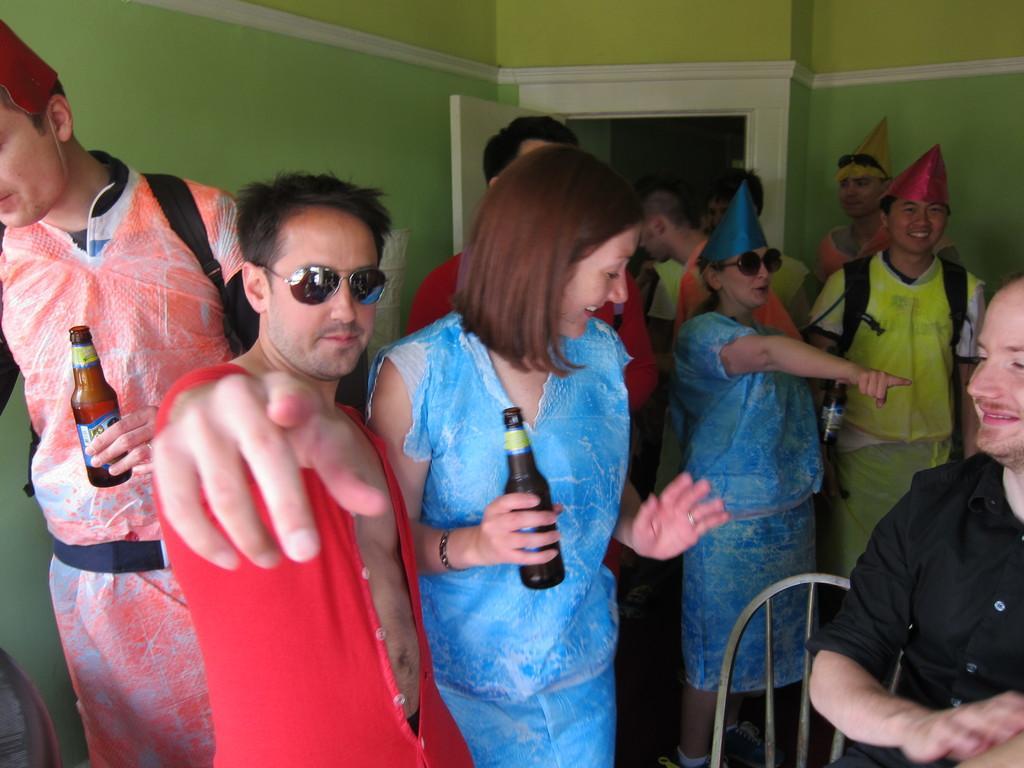Describe this image in one or two sentences. In this image there are group of people with hats and spectacles are standing, three persons holding the bottles, chair , and in the background there is a wall, door. 